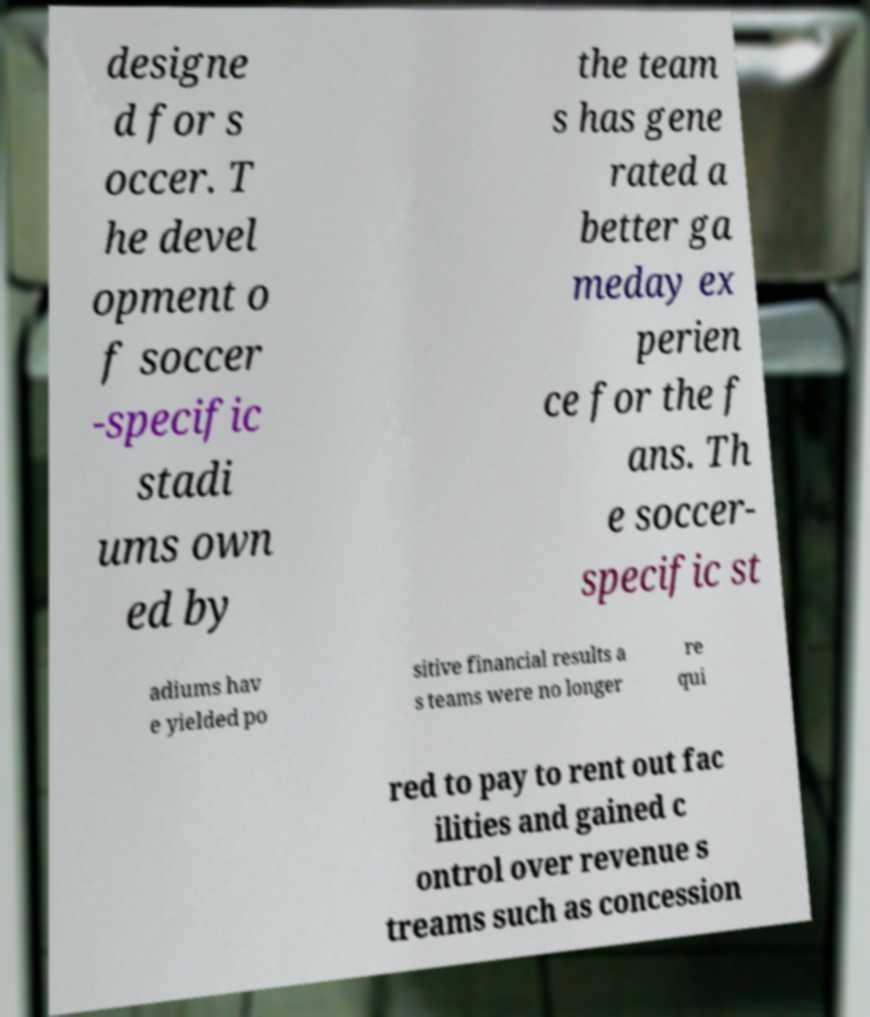Please identify and transcribe the text found in this image. designe d for s occer. T he devel opment o f soccer -specific stadi ums own ed by the team s has gene rated a better ga meday ex perien ce for the f ans. Th e soccer- specific st adiums hav e yielded po sitive financial results a s teams were no longer re qui red to pay to rent out fac ilities and gained c ontrol over revenue s treams such as concession 